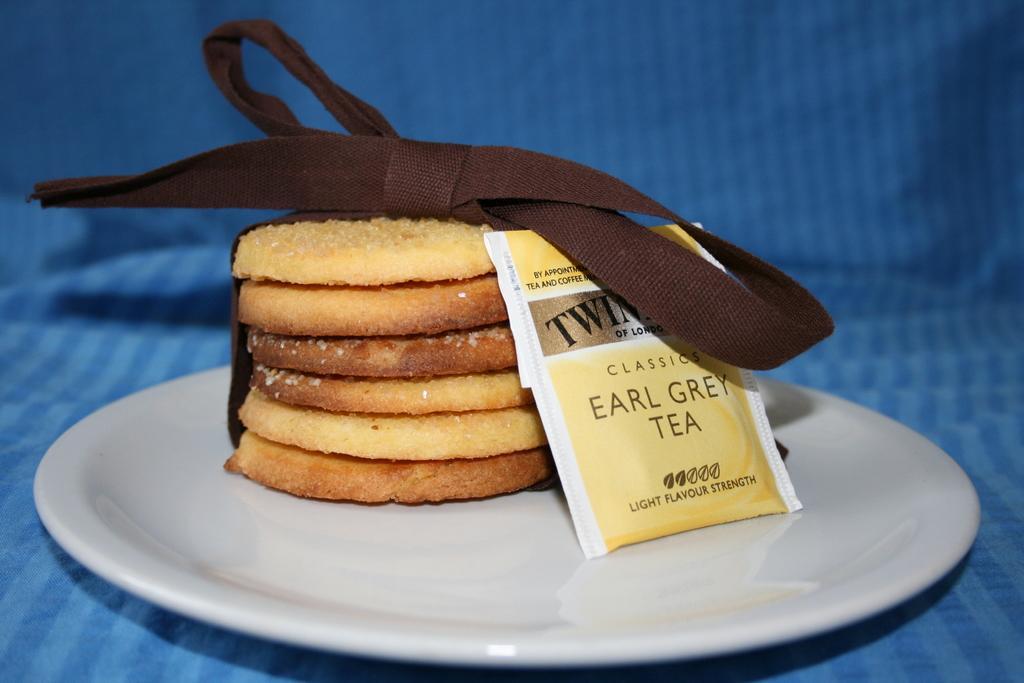Please provide a concise description of this image. In the picture I can see food items on the plate. I can see some text tags.  